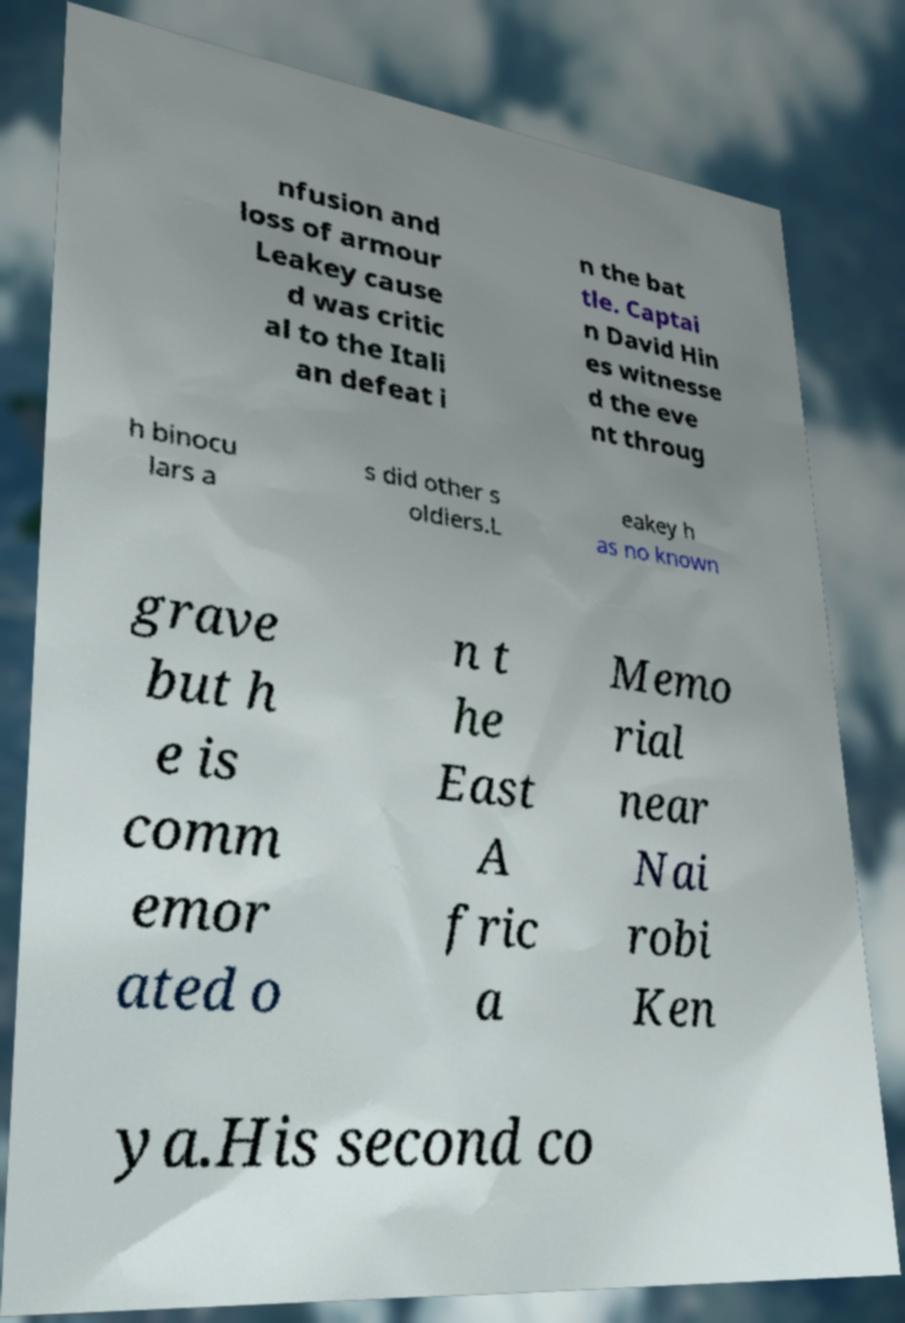Please read and relay the text visible in this image. What does it say? nfusion and loss of armour Leakey cause d was critic al to the Itali an defeat i n the bat tle. Captai n David Hin es witnesse d the eve nt throug h binocu lars a s did other s oldiers.L eakey h as no known grave but h e is comm emor ated o n t he East A fric a Memo rial near Nai robi Ken ya.His second co 